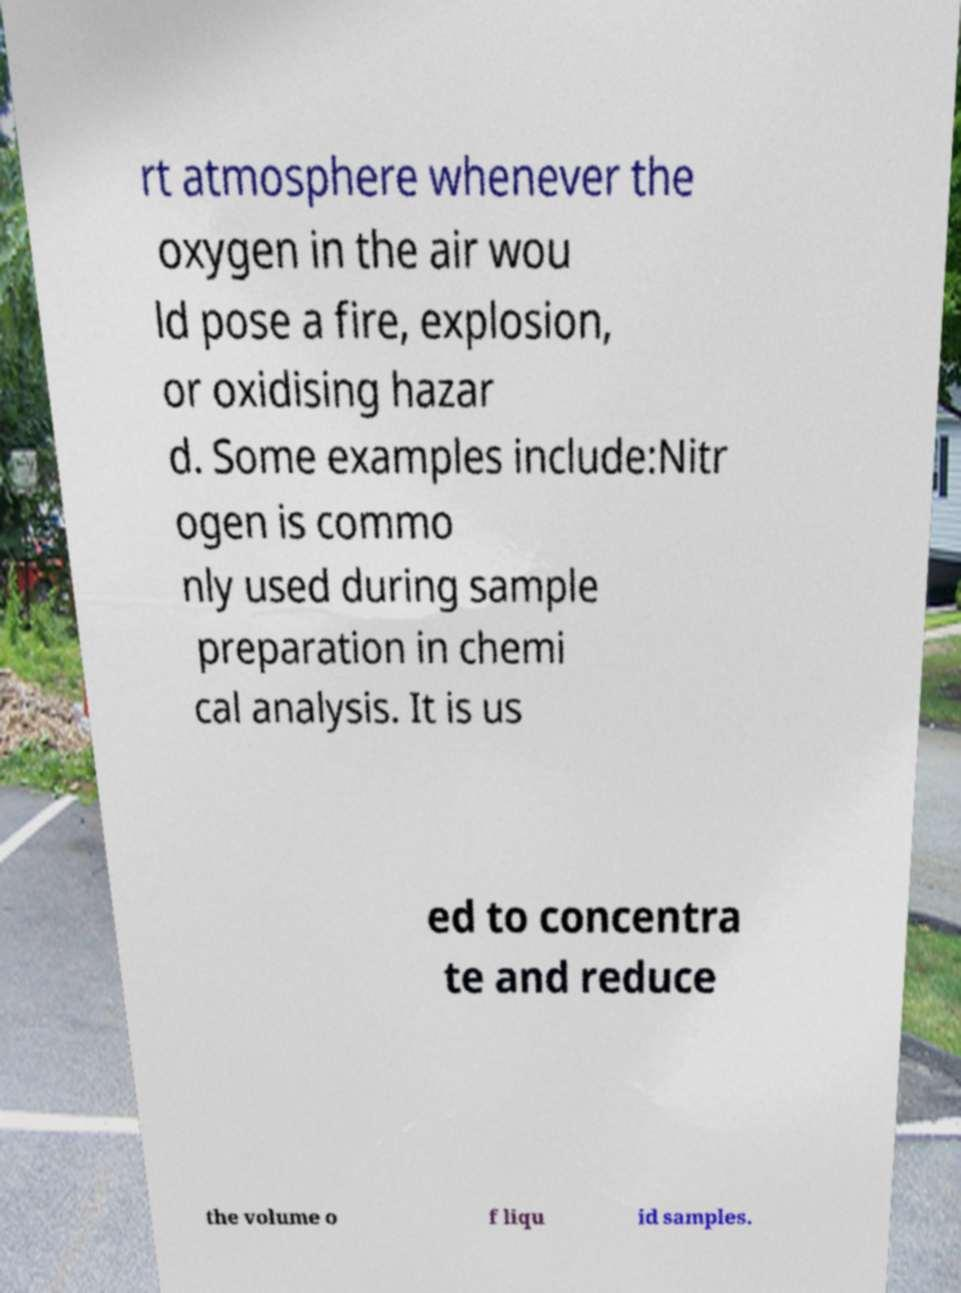There's text embedded in this image that I need extracted. Can you transcribe it verbatim? rt atmosphere whenever the oxygen in the air wou ld pose a fire, explosion, or oxidising hazar d. Some examples include:Nitr ogen is commo nly used during sample preparation in chemi cal analysis. It is us ed to concentra te and reduce the volume o f liqu id samples. 